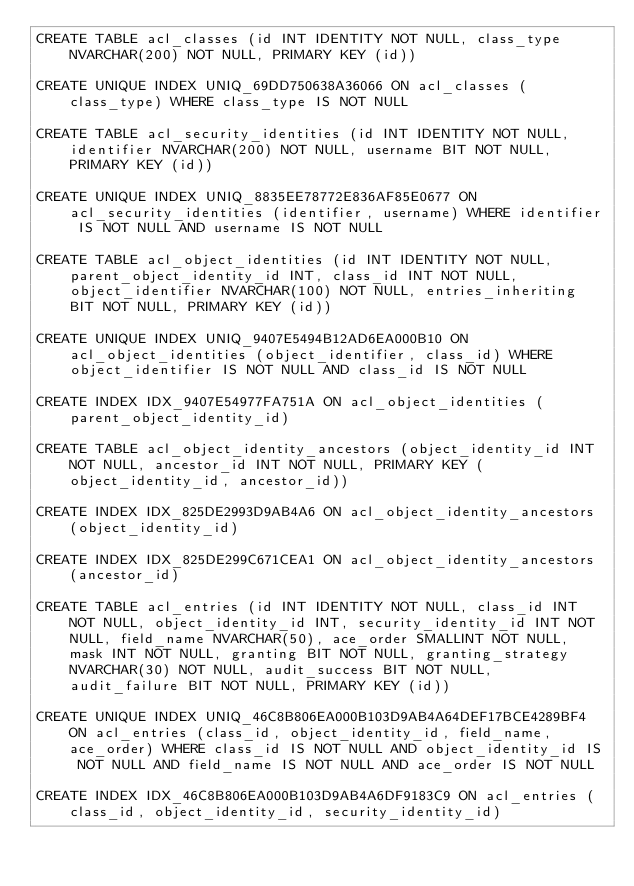Convert code to text. <code><loc_0><loc_0><loc_500><loc_500><_SQL_>CREATE TABLE acl_classes (id INT IDENTITY NOT NULL, class_type NVARCHAR(200) NOT NULL, PRIMARY KEY (id))

CREATE UNIQUE INDEX UNIQ_69DD750638A36066 ON acl_classes (class_type) WHERE class_type IS NOT NULL

CREATE TABLE acl_security_identities (id INT IDENTITY NOT NULL, identifier NVARCHAR(200) NOT NULL, username BIT NOT NULL, PRIMARY KEY (id))

CREATE UNIQUE INDEX UNIQ_8835EE78772E836AF85E0677 ON acl_security_identities (identifier, username) WHERE identifier IS NOT NULL AND username IS NOT NULL

CREATE TABLE acl_object_identities (id INT IDENTITY NOT NULL, parent_object_identity_id INT, class_id INT NOT NULL, object_identifier NVARCHAR(100) NOT NULL, entries_inheriting BIT NOT NULL, PRIMARY KEY (id))

CREATE UNIQUE INDEX UNIQ_9407E5494B12AD6EA000B10 ON acl_object_identities (object_identifier, class_id) WHERE object_identifier IS NOT NULL AND class_id IS NOT NULL

CREATE INDEX IDX_9407E54977FA751A ON acl_object_identities (parent_object_identity_id)

CREATE TABLE acl_object_identity_ancestors (object_identity_id INT NOT NULL, ancestor_id INT NOT NULL, PRIMARY KEY (object_identity_id, ancestor_id))

CREATE INDEX IDX_825DE2993D9AB4A6 ON acl_object_identity_ancestors (object_identity_id)

CREATE INDEX IDX_825DE299C671CEA1 ON acl_object_identity_ancestors (ancestor_id)

CREATE TABLE acl_entries (id INT IDENTITY NOT NULL, class_id INT NOT NULL, object_identity_id INT, security_identity_id INT NOT NULL, field_name NVARCHAR(50), ace_order SMALLINT NOT NULL, mask INT NOT NULL, granting BIT NOT NULL, granting_strategy NVARCHAR(30) NOT NULL, audit_success BIT NOT NULL, audit_failure BIT NOT NULL, PRIMARY KEY (id))

CREATE UNIQUE INDEX UNIQ_46C8B806EA000B103D9AB4A64DEF17BCE4289BF4 ON acl_entries (class_id, object_identity_id, field_name, ace_order) WHERE class_id IS NOT NULL AND object_identity_id IS NOT NULL AND field_name IS NOT NULL AND ace_order IS NOT NULL

CREATE INDEX IDX_46C8B806EA000B103D9AB4A6DF9183C9 ON acl_entries (class_id, object_identity_id, security_identity_id)
</code> 